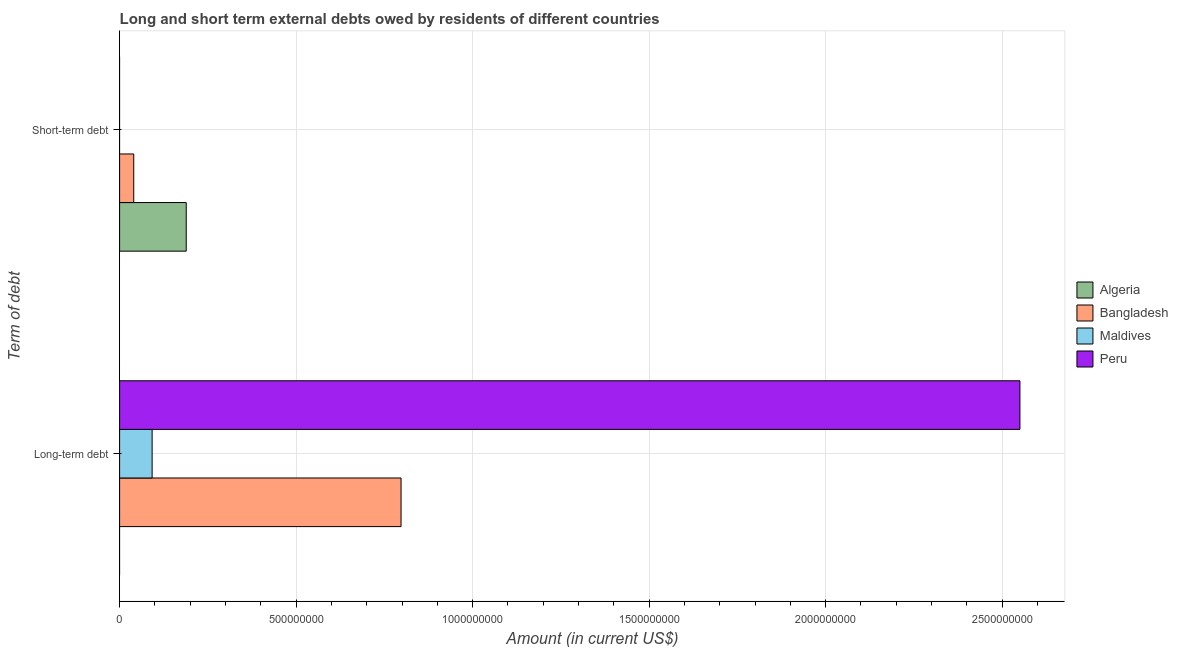How many groups of bars are there?
Offer a very short reply. 2. Are the number of bars on each tick of the Y-axis equal?
Make the answer very short. No. What is the label of the 1st group of bars from the top?
Your answer should be very brief. Short-term debt. What is the short-term debts owed by residents in Bangladesh?
Give a very brief answer. 4.00e+07. Across all countries, what is the maximum long-term debts owed by residents?
Provide a short and direct response. 2.55e+09. Across all countries, what is the minimum short-term debts owed by residents?
Keep it short and to the point. 0. In which country was the short-term debts owed by residents maximum?
Your answer should be very brief. Algeria. What is the total short-term debts owed by residents in the graph?
Your answer should be very brief. 2.29e+08. What is the difference between the short-term debts owed by residents in Algeria and that in Bangladesh?
Your answer should be compact. 1.49e+08. What is the average long-term debts owed by residents per country?
Offer a very short reply. 8.60e+08. What is the difference between the short-term debts owed by residents and long-term debts owed by residents in Bangladesh?
Your answer should be compact. -7.57e+08. What is the ratio of the long-term debts owed by residents in Maldives to that in Bangladesh?
Your answer should be compact. 0.12. Is the long-term debts owed by residents in Bangladesh less than that in Maldives?
Provide a short and direct response. No. Are all the bars in the graph horizontal?
Provide a succinct answer. Yes. How many countries are there in the graph?
Offer a terse response. 4. Are the values on the major ticks of X-axis written in scientific E-notation?
Keep it short and to the point. No. Does the graph contain grids?
Make the answer very short. Yes. How are the legend labels stacked?
Offer a terse response. Vertical. What is the title of the graph?
Your response must be concise. Long and short term external debts owed by residents of different countries. What is the label or title of the X-axis?
Provide a succinct answer. Amount (in current US$). What is the label or title of the Y-axis?
Provide a short and direct response. Term of debt. What is the Amount (in current US$) of Algeria in Long-term debt?
Provide a succinct answer. 0. What is the Amount (in current US$) in Bangladesh in Long-term debt?
Keep it short and to the point. 7.97e+08. What is the Amount (in current US$) in Maldives in Long-term debt?
Offer a very short reply. 9.21e+07. What is the Amount (in current US$) in Peru in Long-term debt?
Your answer should be very brief. 2.55e+09. What is the Amount (in current US$) in Algeria in Short-term debt?
Offer a terse response. 1.89e+08. What is the Amount (in current US$) in Bangladesh in Short-term debt?
Keep it short and to the point. 4.00e+07. What is the Amount (in current US$) of Maldives in Short-term debt?
Offer a terse response. 0. Across all Term of debt, what is the maximum Amount (in current US$) in Algeria?
Offer a terse response. 1.89e+08. Across all Term of debt, what is the maximum Amount (in current US$) of Bangladesh?
Ensure brevity in your answer.  7.97e+08. Across all Term of debt, what is the maximum Amount (in current US$) of Maldives?
Give a very brief answer. 9.21e+07. Across all Term of debt, what is the maximum Amount (in current US$) of Peru?
Offer a very short reply. 2.55e+09. Across all Term of debt, what is the minimum Amount (in current US$) in Algeria?
Provide a short and direct response. 0. Across all Term of debt, what is the minimum Amount (in current US$) of Bangladesh?
Offer a terse response. 4.00e+07. What is the total Amount (in current US$) in Algeria in the graph?
Your answer should be very brief. 1.89e+08. What is the total Amount (in current US$) of Bangladesh in the graph?
Your answer should be very brief. 8.37e+08. What is the total Amount (in current US$) of Maldives in the graph?
Offer a terse response. 9.21e+07. What is the total Amount (in current US$) of Peru in the graph?
Ensure brevity in your answer.  2.55e+09. What is the difference between the Amount (in current US$) of Bangladesh in Long-term debt and that in Short-term debt?
Your response must be concise. 7.57e+08. What is the average Amount (in current US$) in Algeria per Term of debt?
Provide a short and direct response. 9.44e+07. What is the average Amount (in current US$) of Bangladesh per Term of debt?
Make the answer very short. 4.19e+08. What is the average Amount (in current US$) in Maldives per Term of debt?
Give a very brief answer. 4.61e+07. What is the average Amount (in current US$) in Peru per Term of debt?
Offer a terse response. 1.28e+09. What is the difference between the Amount (in current US$) of Bangladesh and Amount (in current US$) of Maldives in Long-term debt?
Offer a terse response. 7.05e+08. What is the difference between the Amount (in current US$) of Bangladesh and Amount (in current US$) of Peru in Long-term debt?
Your answer should be compact. -1.75e+09. What is the difference between the Amount (in current US$) in Maldives and Amount (in current US$) in Peru in Long-term debt?
Provide a short and direct response. -2.46e+09. What is the difference between the Amount (in current US$) of Algeria and Amount (in current US$) of Bangladesh in Short-term debt?
Provide a short and direct response. 1.49e+08. What is the ratio of the Amount (in current US$) in Bangladesh in Long-term debt to that in Short-term debt?
Make the answer very short. 19.93. What is the difference between the highest and the second highest Amount (in current US$) of Bangladesh?
Offer a terse response. 7.57e+08. What is the difference between the highest and the lowest Amount (in current US$) in Algeria?
Give a very brief answer. 1.89e+08. What is the difference between the highest and the lowest Amount (in current US$) of Bangladesh?
Your answer should be very brief. 7.57e+08. What is the difference between the highest and the lowest Amount (in current US$) in Maldives?
Give a very brief answer. 9.21e+07. What is the difference between the highest and the lowest Amount (in current US$) in Peru?
Your response must be concise. 2.55e+09. 